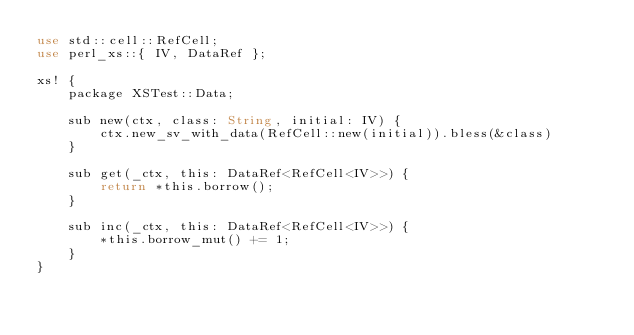<code> <loc_0><loc_0><loc_500><loc_500><_Rust_>use std::cell::RefCell;
use perl_xs::{ IV, DataRef };

xs! {
    package XSTest::Data;

    sub new(ctx, class: String, initial: IV) {
        ctx.new_sv_with_data(RefCell::new(initial)).bless(&class)
    }

    sub get(_ctx, this: DataRef<RefCell<IV>>) {
        return *this.borrow();
    }

    sub inc(_ctx, this: DataRef<RefCell<IV>>) {
        *this.borrow_mut() += 1;
    }
}
</code> 